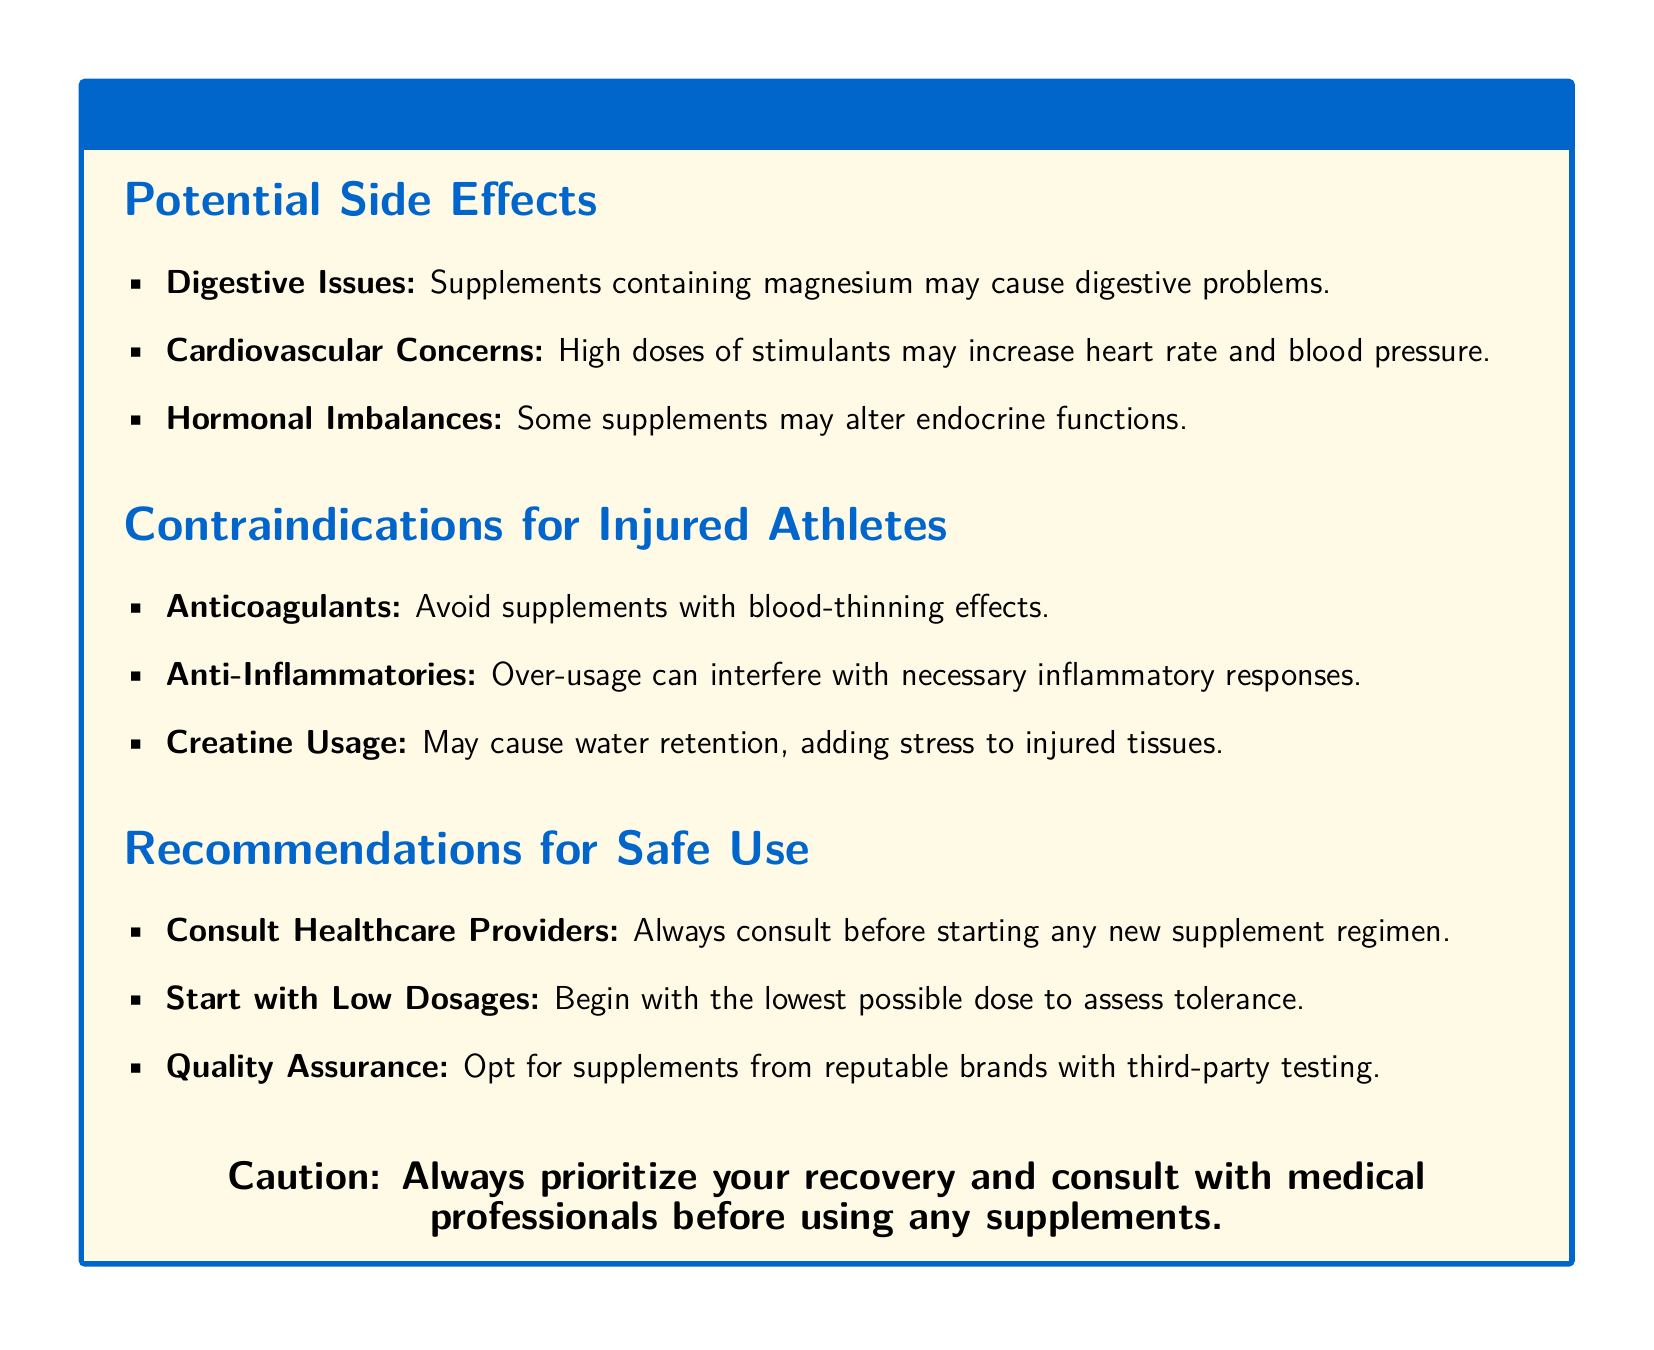what are digestive issues? Digestive issues are problems that may arise from supplements containing magnesium.
Answer: digestive problems what should injured athletes avoid taking? Injured athletes should avoid supplements with blood-thinning effects.
Answer: anticoagulants what effect can high doses of stimulants have? High doses of stimulants may increase heart rate and blood pressure.
Answer: increase heart rate and blood pressure what impact does creatine have on injured tissues? Creatine may cause water retention, adding stress to injured tissues.
Answer: stress to injured tissues what is recommended before starting new supplements? It is recommended to consult healthcare providers before starting any new supplement regimen.
Answer: consult healthcare providers how should one begin with supplement dosages? One should start with the lowest possible dose to assess tolerance.
Answer: lowest possible dose 